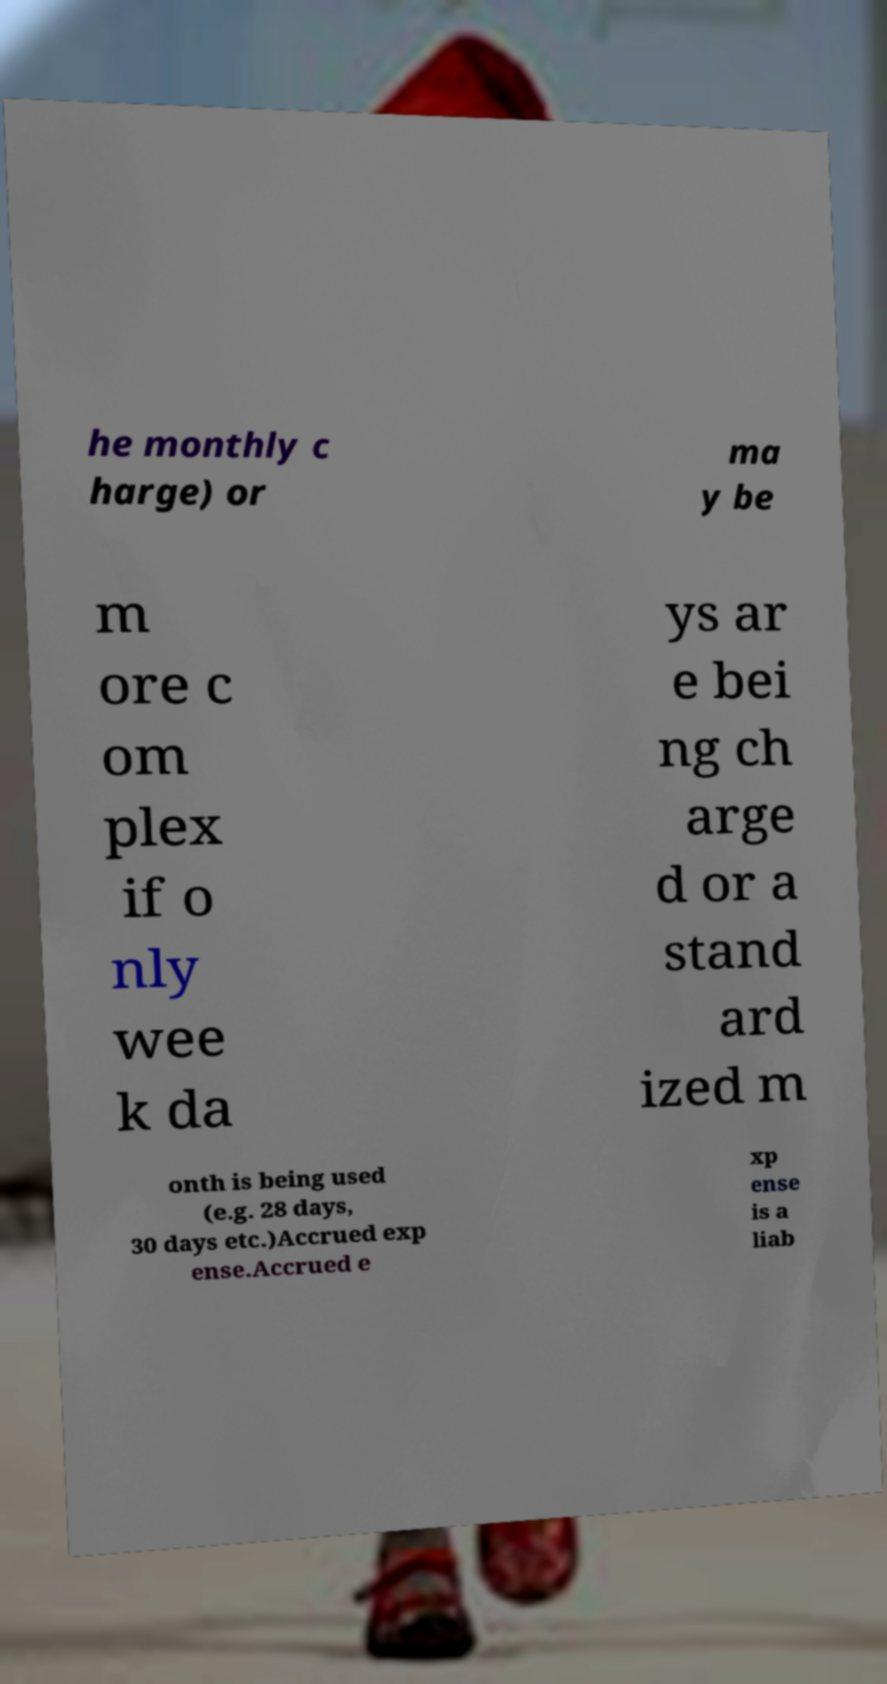Please read and relay the text visible in this image. What does it say? he monthly c harge) or ma y be m ore c om plex if o nly wee k da ys ar e bei ng ch arge d or a stand ard ized m onth is being used (e.g. 28 days, 30 days etc.)Accrued exp ense.Accrued e xp ense is a liab 